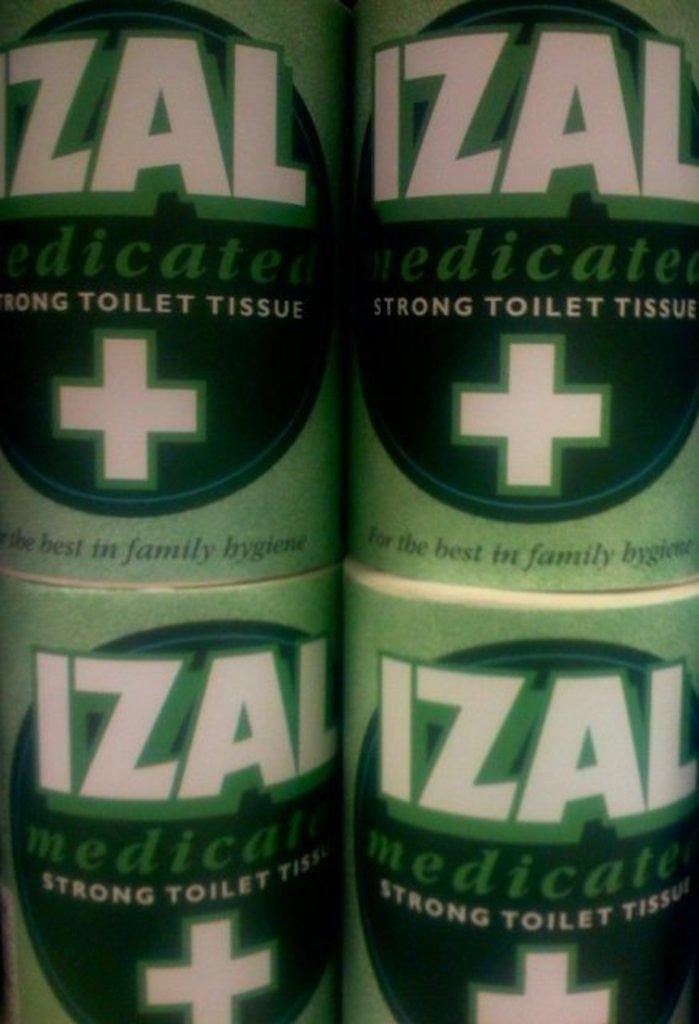<image>
Summarize the visual content of the image. Four packets of toilet tissues with green packaging. 